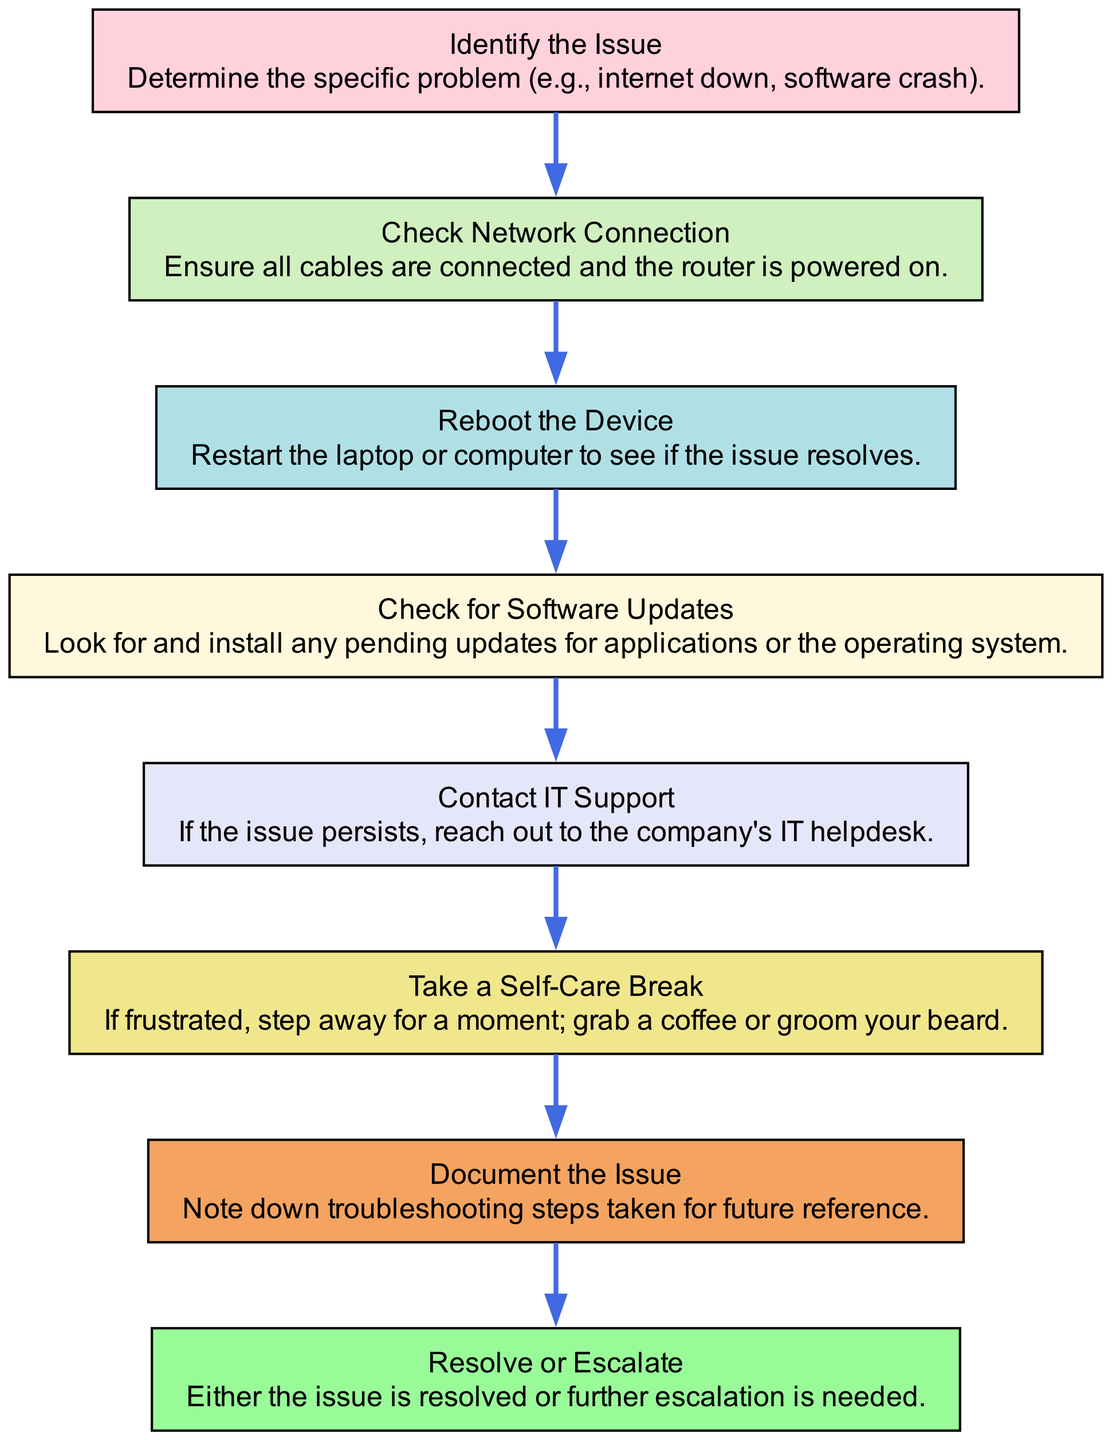What is the first step in the troubleshooting process? The diagram indicates that the first step is to "Identify the Issue," which is where you determine the specific problem at hand.
Answer: Identify the Issue How many nodes are in the diagram? Counting each unique process or step in the diagram, there are a total of eight nodes, including the start and end nodes.
Answer: 8 What happens if the issue persists after contacting IT support? After reaching out to IT support, the next step as per the diagram is to take a self-care break if the issue still persists, indicating a need to step away from the problem momentarily.
Answer: Take a Self-Care Break Which action is taken after rebooting the device? Based on the flow chart, the next action after rebooting the device is to check for software updates, indicating that the troubleshooting process continues with updating applications or the operating system.
Answer: Check for Software Updates What is the last action indicated in the flow chart? The final action in the flow chart is "Resolve or Escalate," which signifies that the troubleshooting process concludes either with solving the problem or deciding to escalate it further.
Answer: Resolve or Escalate If the steps are followed sequentially, which step comes after "Document the Issue"? According to the flow of the diagram, after "Document the Issue," you reach the step marked as "Resolve or Escalate," demonstrating the final stage of the troubleshooting process.
Answer: Resolve or Escalate How does the flow chart encourage a brief break during troubleshooting? The diagram explicitly includes a step labeled "Take a Self-Care Break," which suggests that if frustration occurs during the troubleshooting process, taking a break can be beneficial for mental clarity and focus.
Answer: Take a Self-Care Break What do you do if the network connection is okay? If the network connection is confirmed good after checking, the flow chart suggests continuing to the next step, which is rebooting the device, indicating the need to rule out device-specific issues.
Answer: Reboot the Device 